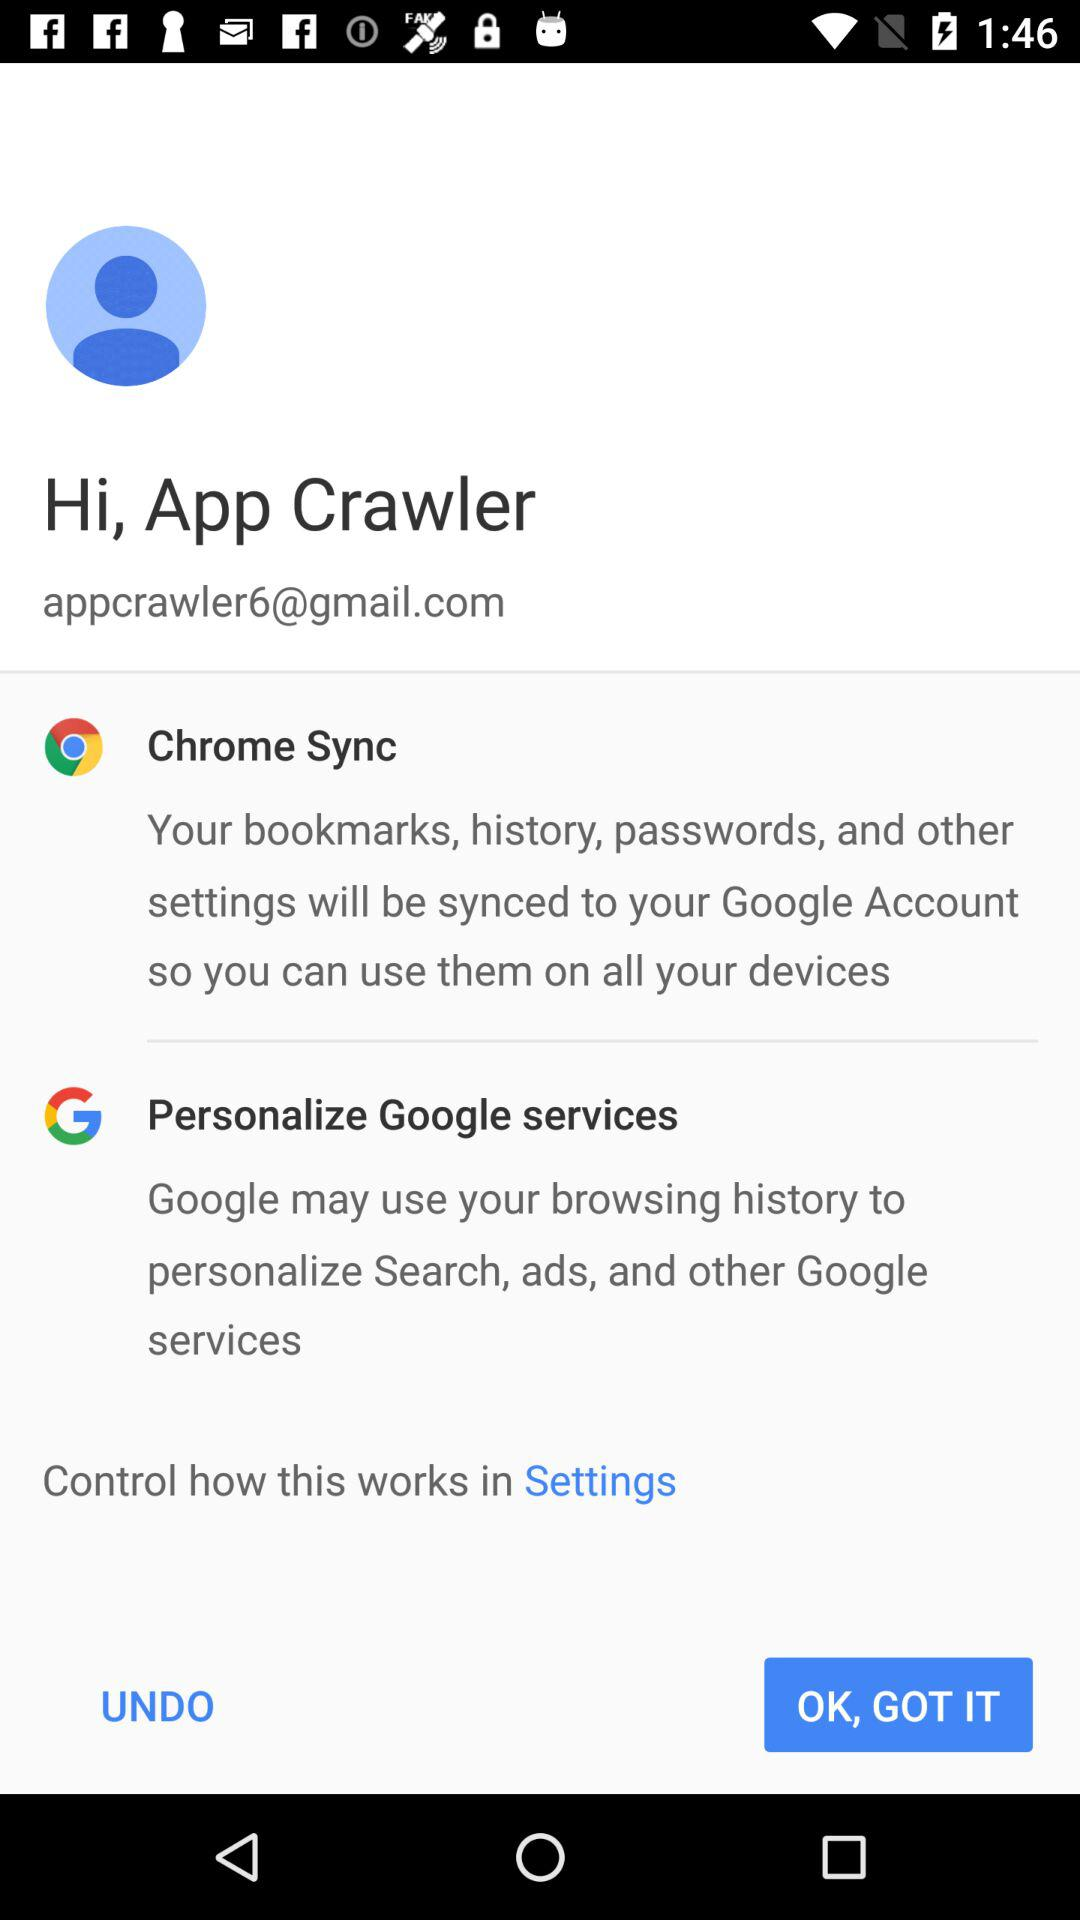How many items are under the 'Sync and personalization' header?
Answer the question using a single word or phrase. 2 